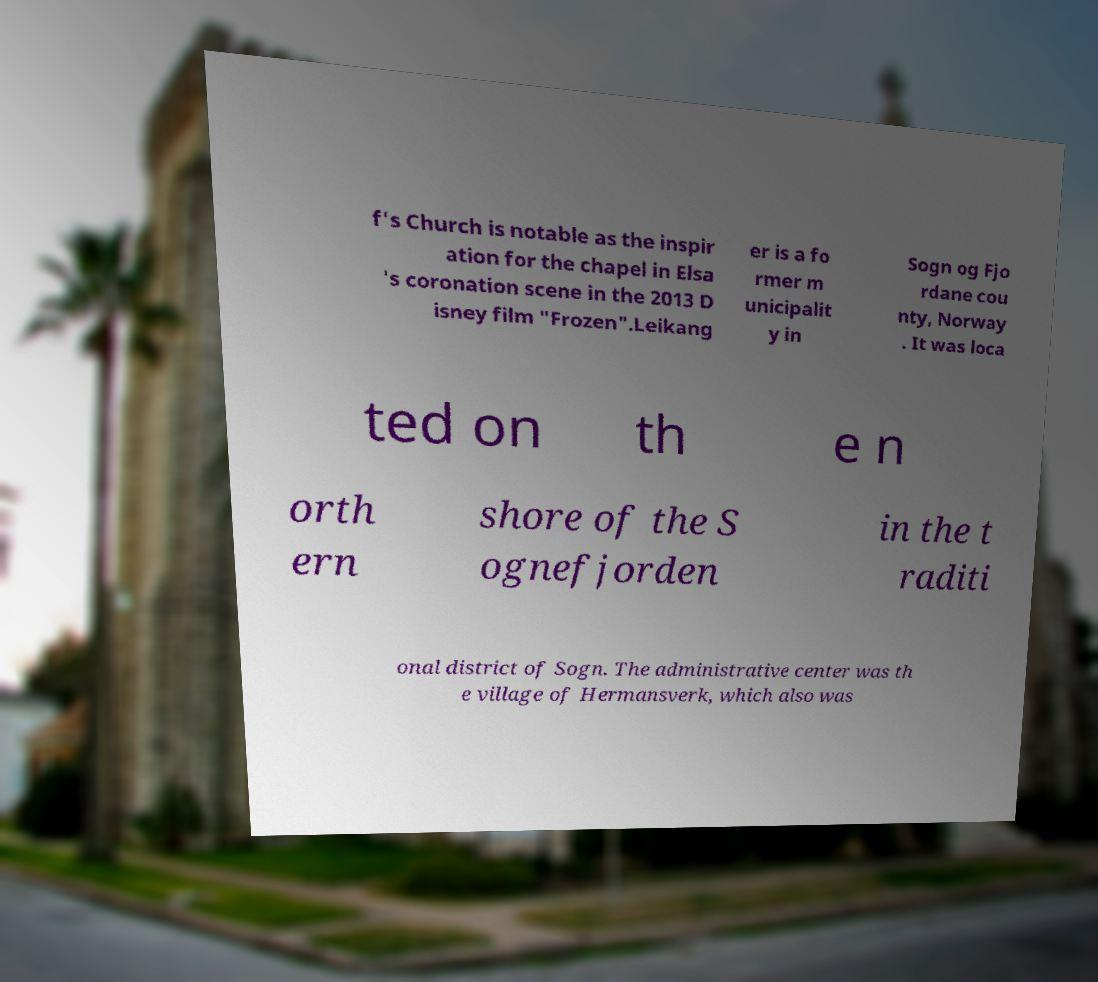There's text embedded in this image that I need extracted. Can you transcribe it verbatim? f's Church is notable as the inspir ation for the chapel in Elsa 's coronation scene in the 2013 D isney film "Frozen".Leikang er is a fo rmer m unicipalit y in Sogn og Fjo rdane cou nty, Norway . It was loca ted on th e n orth ern shore of the S ognefjorden in the t raditi onal district of Sogn. The administrative center was th e village of Hermansverk, which also was 